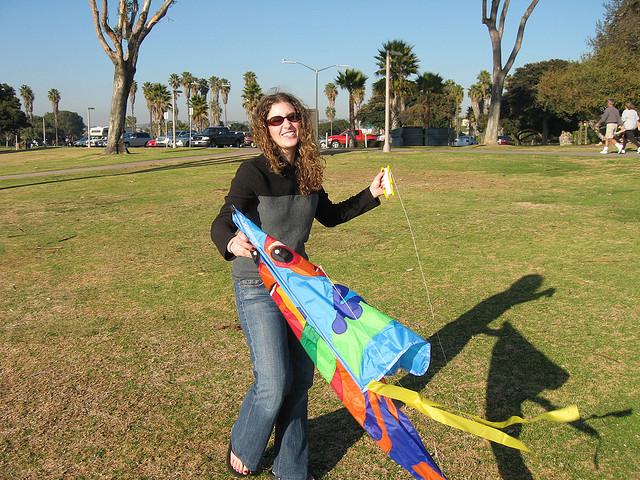Does the woman appear to be elderly?
Answer briefly. No. How many red cars are in this picture?
Answer briefly. 2. Is the girl wearing glasses?
Quick response, please. Yes. 